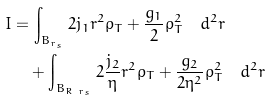<formula> <loc_0><loc_0><loc_500><loc_500>I & = \int _ { B _ { r _ { s } } } 2 j _ { 1 } r ^ { 2 } \rho _ { T } + \frac { g _ { 1 } } { 2 } \rho _ { T } ^ { 2 } \quad d ^ { 2 } r \\ & \quad + \int _ { B _ { R \ r _ { s } } } 2 \frac { j _ { 2 } } { \eta } r ^ { 2 } \rho _ { T } + \frac { g _ { 2 } } { 2 \eta ^ { 2 } } \rho _ { T } ^ { 2 } \quad d ^ { 2 } r</formula> 